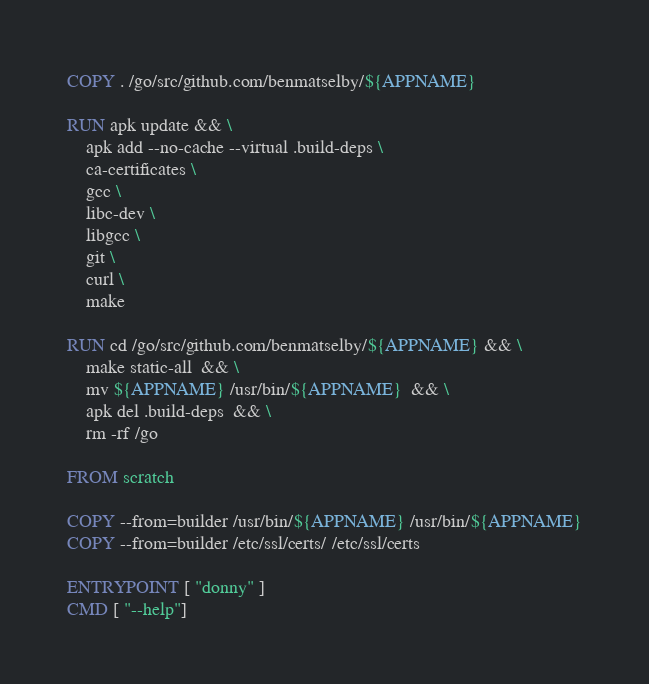Convert code to text. <code><loc_0><loc_0><loc_500><loc_500><_Dockerfile_>COPY . /go/src/github.com/benmatselby/${APPNAME}

RUN apk update && \
	apk add --no-cache --virtual .build-deps \
	ca-certificates \
	gcc \
	libc-dev \
	libgcc \
	git \
	curl \
	make

RUN cd /go/src/github.com/benmatselby/${APPNAME} && \
	make static-all  && \
	mv ${APPNAME} /usr/bin/${APPNAME}  && \
	apk del .build-deps  && \
	rm -rf /go

FROM scratch

COPY --from=builder /usr/bin/${APPNAME} /usr/bin/${APPNAME}
COPY --from=builder /etc/ssl/certs/ /etc/ssl/certs

ENTRYPOINT [ "donny" ]
CMD [ "--help"]
</code> 